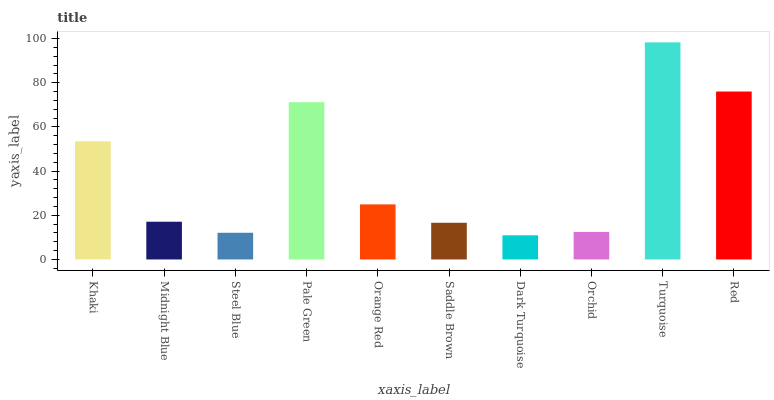Is Dark Turquoise the minimum?
Answer yes or no. Yes. Is Turquoise the maximum?
Answer yes or no. Yes. Is Midnight Blue the minimum?
Answer yes or no. No. Is Midnight Blue the maximum?
Answer yes or no. No. Is Khaki greater than Midnight Blue?
Answer yes or no. Yes. Is Midnight Blue less than Khaki?
Answer yes or no. Yes. Is Midnight Blue greater than Khaki?
Answer yes or no. No. Is Khaki less than Midnight Blue?
Answer yes or no. No. Is Orange Red the high median?
Answer yes or no. Yes. Is Midnight Blue the low median?
Answer yes or no. Yes. Is Khaki the high median?
Answer yes or no. No. Is Steel Blue the low median?
Answer yes or no. No. 